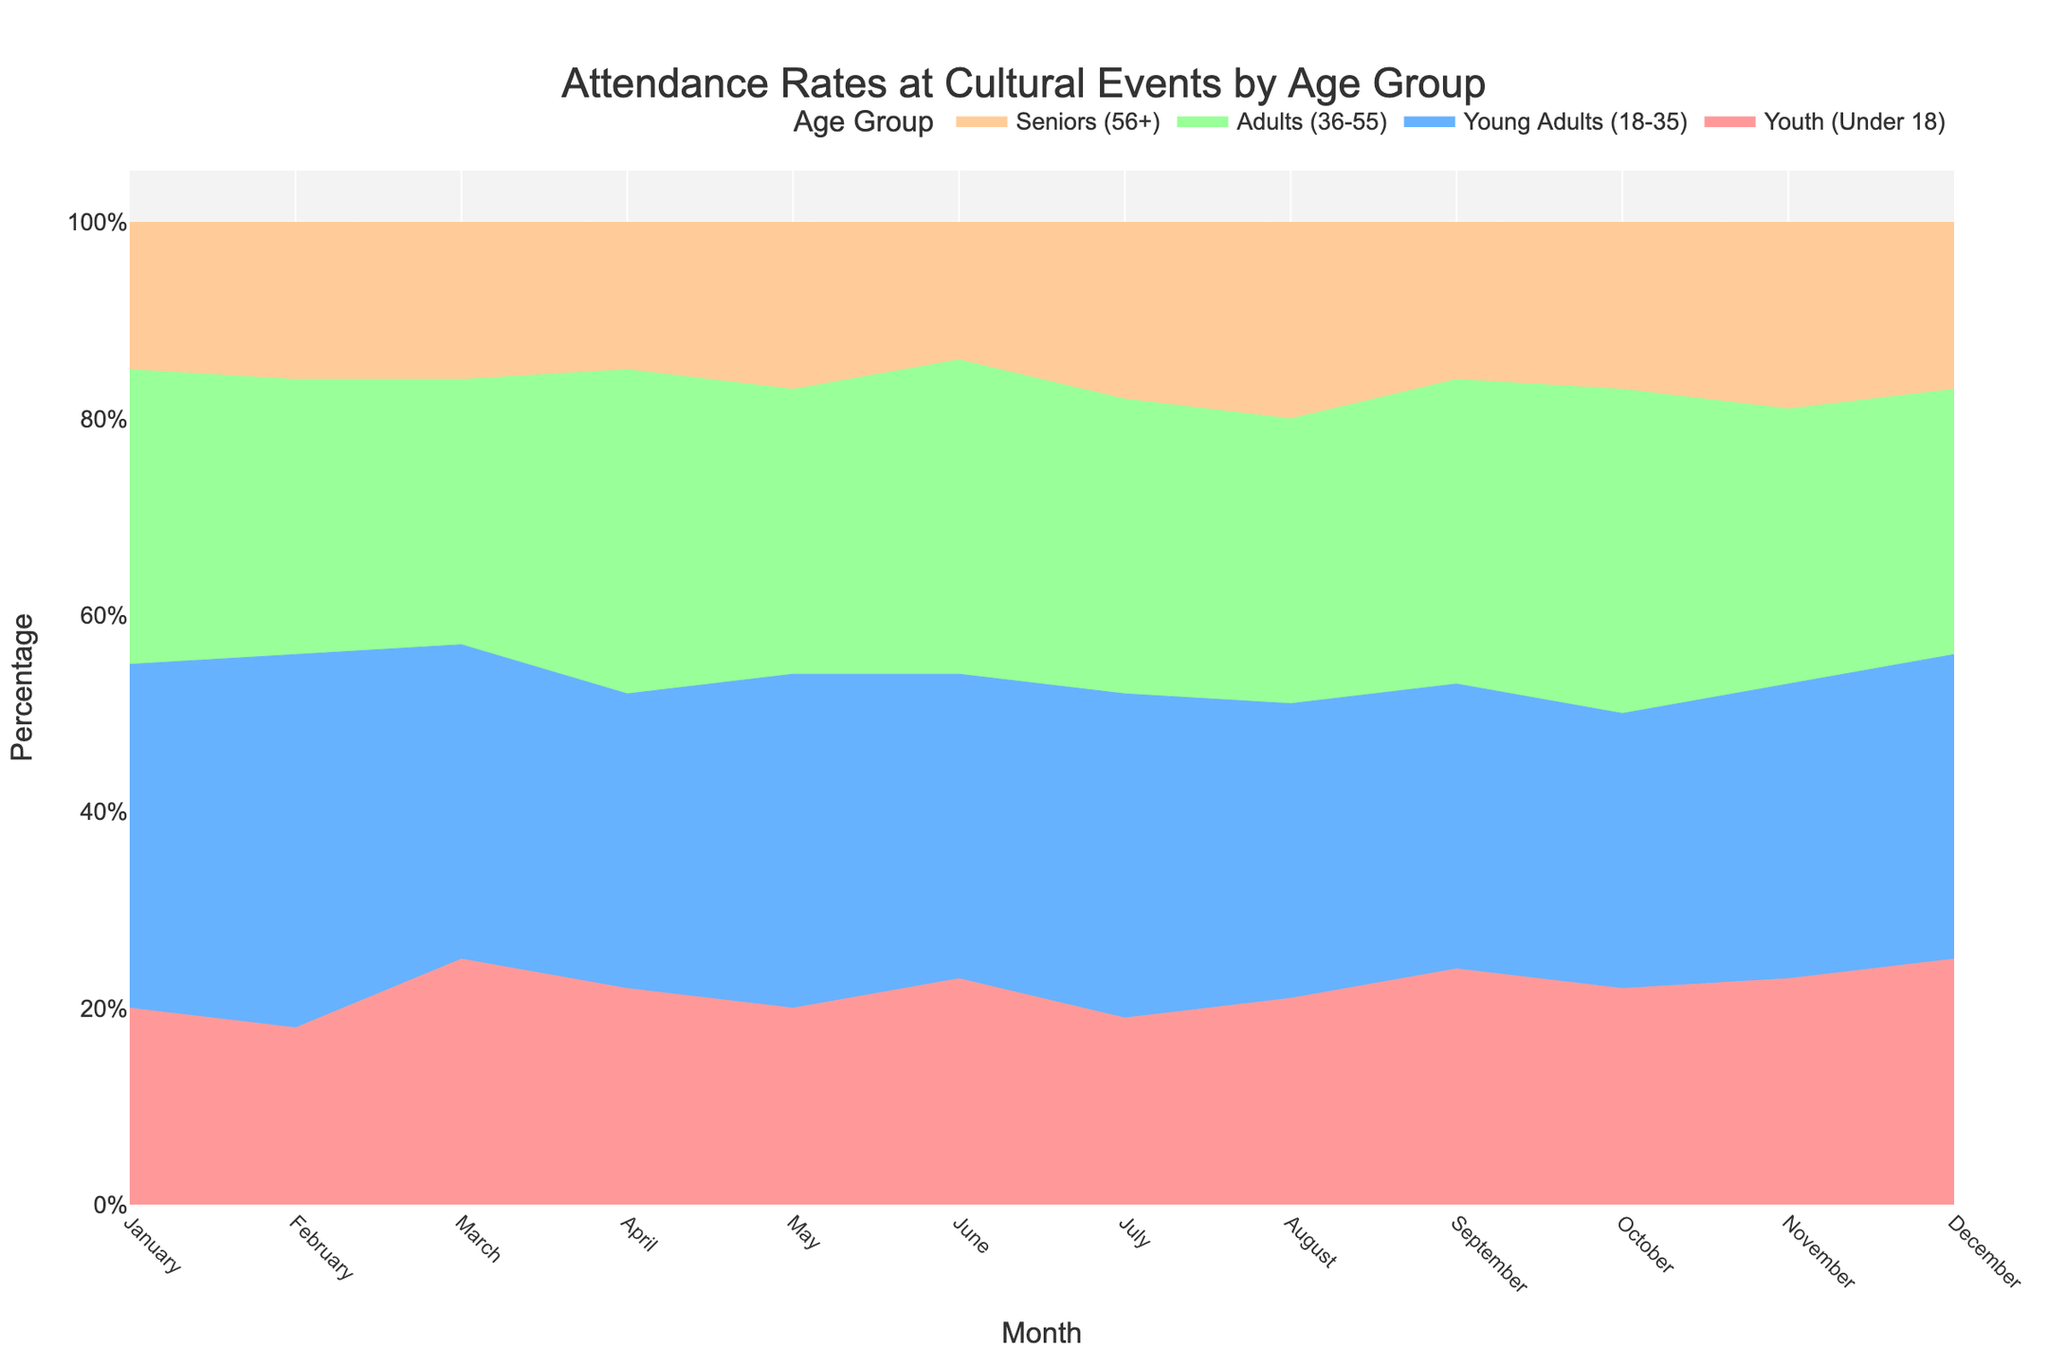What is the title of the chart? To find the title, look at the top of the chart where it is usually located.
Answer: Attendance Rates at Cultural Events by Age Group Which age group has the highest attendance percentage in January? In January, the Young Adults (18-35) category starts at the bottom and reaches up to approximately 35%, which is the highest among all categories.
Answer: Young Adults (18-35) How does the percentage of Youth (Under 18) attendance change from January to December? Observe the area representing Youth (Under 18) from January to December. Notice if its width increases, decreases, or stays about the same.
Answer: Increases Compare the Senior (56+) attendance rate in August and September. Which month had a higher rate? Check the top layer of the stacked area chart for August and September. September's section for Seniors is smaller than August's.
Answer: August What is the average attendance percentage of Adults (36-55) over the year? Sum the percentage values for Adults (36-55) for each month and then divide by the number of months (12). The percentages are roughly 30, 28, 27, 33, 29, 32, 30, 29, 31, 33, 28, and 27. Average is approximated by (30+28+27+33+29+32+30+29+31+33+28+27)/12.
Answer: 29.75% In which month did Young Adults (18-35) have their lowest attendance percentage? Look for the smallest section (color-coded) representing Young Adults (18-35) across the months.
Answer: October Did the percentage of Young Adults (18-35) attendance increase or decrease from February to March? Compare the size of the Young Adults area from February to March. The area decreases from 38% to 32%.
Answer: Decrease Which month had the overall highest attendance of Seniors (56+)? Examine the top portion of each month's stacked area where Seniors (56+) are located.
Answer: August What percentage of total attendance did Youth (Under 18) represent in March? Check the segment for Youth (Under 18) in March. It starts from 0% and ends just above 25%.
Answer: 25% What is the difference in Senior (56+) attendance percentage between June and December? Compare the Senior (56+) percentages in June and December. June's is 14% and December's is 17%. Calculate the absolute difference: 17% - 14%.
Answer: 3% 